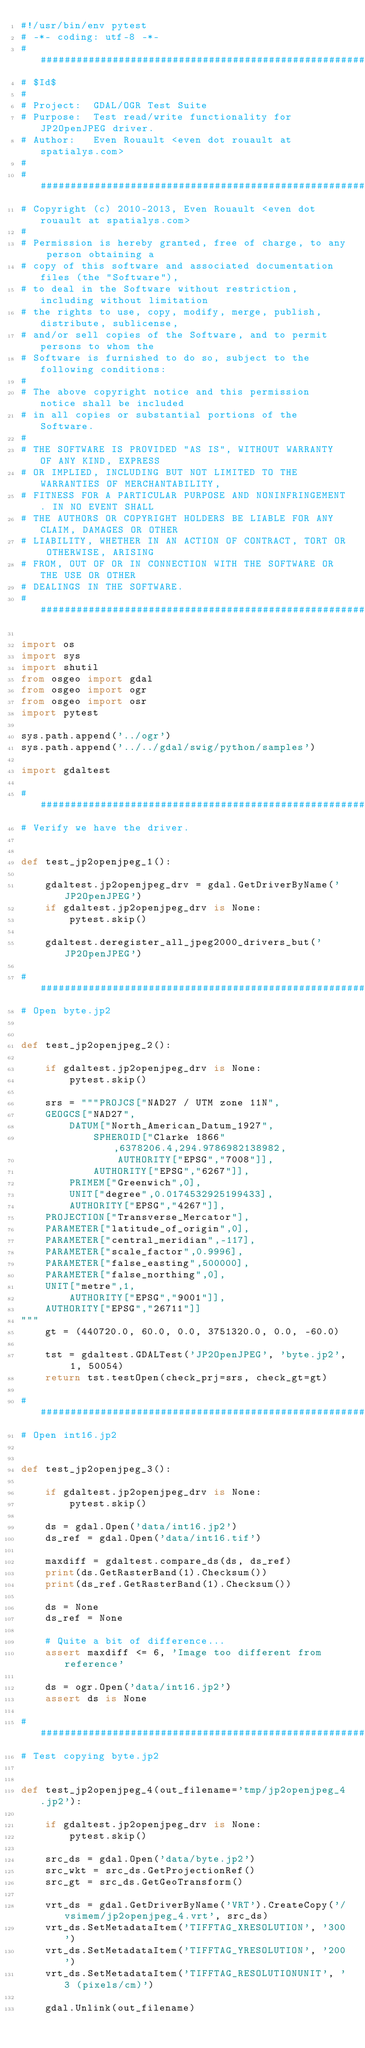Convert code to text. <code><loc_0><loc_0><loc_500><loc_500><_Python_>#!/usr/bin/env pytest
# -*- coding: utf-8 -*-
###############################################################################
# $Id$
#
# Project:  GDAL/OGR Test Suite
# Purpose:  Test read/write functionality for JP2OpenJPEG driver.
# Author:   Even Rouault <even dot rouault at spatialys.com>
#
###############################################################################
# Copyright (c) 2010-2013, Even Rouault <even dot rouault at spatialys.com>
#
# Permission is hereby granted, free of charge, to any person obtaining a
# copy of this software and associated documentation files (the "Software"),
# to deal in the Software without restriction, including without limitation
# the rights to use, copy, modify, merge, publish, distribute, sublicense,
# and/or sell copies of the Software, and to permit persons to whom the
# Software is furnished to do so, subject to the following conditions:
#
# The above copyright notice and this permission notice shall be included
# in all copies or substantial portions of the Software.
#
# THE SOFTWARE IS PROVIDED "AS IS", WITHOUT WARRANTY OF ANY KIND, EXPRESS
# OR IMPLIED, INCLUDING BUT NOT LIMITED TO THE WARRANTIES OF MERCHANTABILITY,
# FITNESS FOR A PARTICULAR PURPOSE AND NONINFRINGEMENT. IN NO EVENT SHALL
# THE AUTHORS OR COPYRIGHT HOLDERS BE LIABLE FOR ANY CLAIM, DAMAGES OR OTHER
# LIABILITY, WHETHER IN AN ACTION OF CONTRACT, TORT OR OTHERWISE, ARISING
# FROM, OUT OF OR IN CONNECTION WITH THE SOFTWARE OR THE USE OR OTHER
# DEALINGS IN THE SOFTWARE.
###############################################################################

import os
import sys
import shutil
from osgeo import gdal
from osgeo import ogr
from osgeo import osr
import pytest

sys.path.append('../ogr')
sys.path.append('../../gdal/swig/python/samples')

import gdaltest

###############################################################################
# Verify we have the driver.


def test_jp2openjpeg_1():

    gdaltest.jp2openjpeg_drv = gdal.GetDriverByName('JP2OpenJPEG')
    if gdaltest.jp2openjpeg_drv is None:
        pytest.skip()

    gdaltest.deregister_all_jpeg2000_drivers_but('JP2OpenJPEG')

###############################################################################
# Open byte.jp2


def test_jp2openjpeg_2():

    if gdaltest.jp2openjpeg_drv is None:
        pytest.skip()

    srs = """PROJCS["NAD27 / UTM zone 11N",
    GEOGCS["NAD27",
        DATUM["North_American_Datum_1927",
            SPHEROID["Clarke 1866",6378206.4,294.9786982138982,
                AUTHORITY["EPSG","7008"]],
            AUTHORITY["EPSG","6267"]],
        PRIMEM["Greenwich",0],
        UNIT["degree",0.0174532925199433],
        AUTHORITY["EPSG","4267"]],
    PROJECTION["Transverse_Mercator"],
    PARAMETER["latitude_of_origin",0],
    PARAMETER["central_meridian",-117],
    PARAMETER["scale_factor",0.9996],
    PARAMETER["false_easting",500000],
    PARAMETER["false_northing",0],
    UNIT["metre",1,
        AUTHORITY["EPSG","9001"]],
    AUTHORITY["EPSG","26711"]]
"""
    gt = (440720.0, 60.0, 0.0, 3751320.0, 0.0, -60.0)

    tst = gdaltest.GDALTest('JP2OpenJPEG', 'byte.jp2', 1, 50054)
    return tst.testOpen(check_prj=srs, check_gt=gt)

###############################################################################
# Open int16.jp2


def test_jp2openjpeg_3():

    if gdaltest.jp2openjpeg_drv is None:
        pytest.skip()

    ds = gdal.Open('data/int16.jp2')
    ds_ref = gdal.Open('data/int16.tif')

    maxdiff = gdaltest.compare_ds(ds, ds_ref)
    print(ds.GetRasterBand(1).Checksum())
    print(ds_ref.GetRasterBand(1).Checksum())

    ds = None
    ds_ref = None

    # Quite a bit of difference...
    assert maxdiff <= 6, 'Image too different from reference'

    ds = ogr.Open('data/int16.jp2')
    assert ds is None

###############################################################################
# Test copying byte.jp2


def test_jp2openjpeg_4(out_filename='tmp/jp2openjpeg_4.jp2'):

    if gdaltest.jp2openjpeg_drv is None:
        pytest.skip()

    src_ds = gdal.Open('data/byte.jp2')
    src_wkt = src_ds.GetProjectionRef()
    src_gt = src_ds.GetGeoTransform()

    vrt_ds = gdal.GetDriverByName('VRT').CreateCopy('/vsimem/jp2openjpeg_4.vrt', src_ds)
    vrt_ds.SetMetadataItem('TIFFTAG_XRESOLUTION', '300')
    vrt_ds.SetMetadataItem('TIFFTAG_YRESOLUTION', '200')
    vrt_ds.SetMetadataItem('TIFFTAG_RESOLUTIONUNIT', '3 (pixels/cm)')

    gdal.Unlink(out_filename)
</code> 